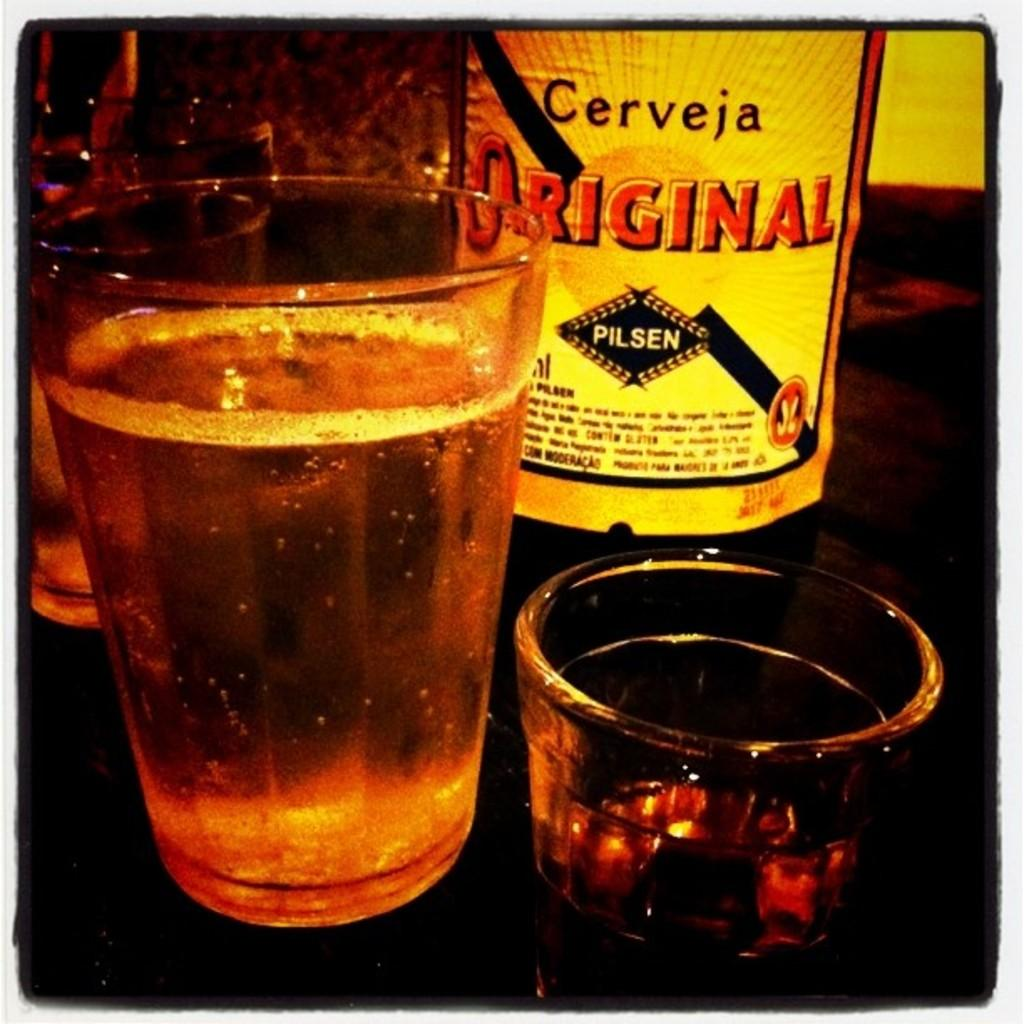<image>
Share a concise interpretation of the image provided. a glass and bottle of Cerveja Original Pilsen on a table 